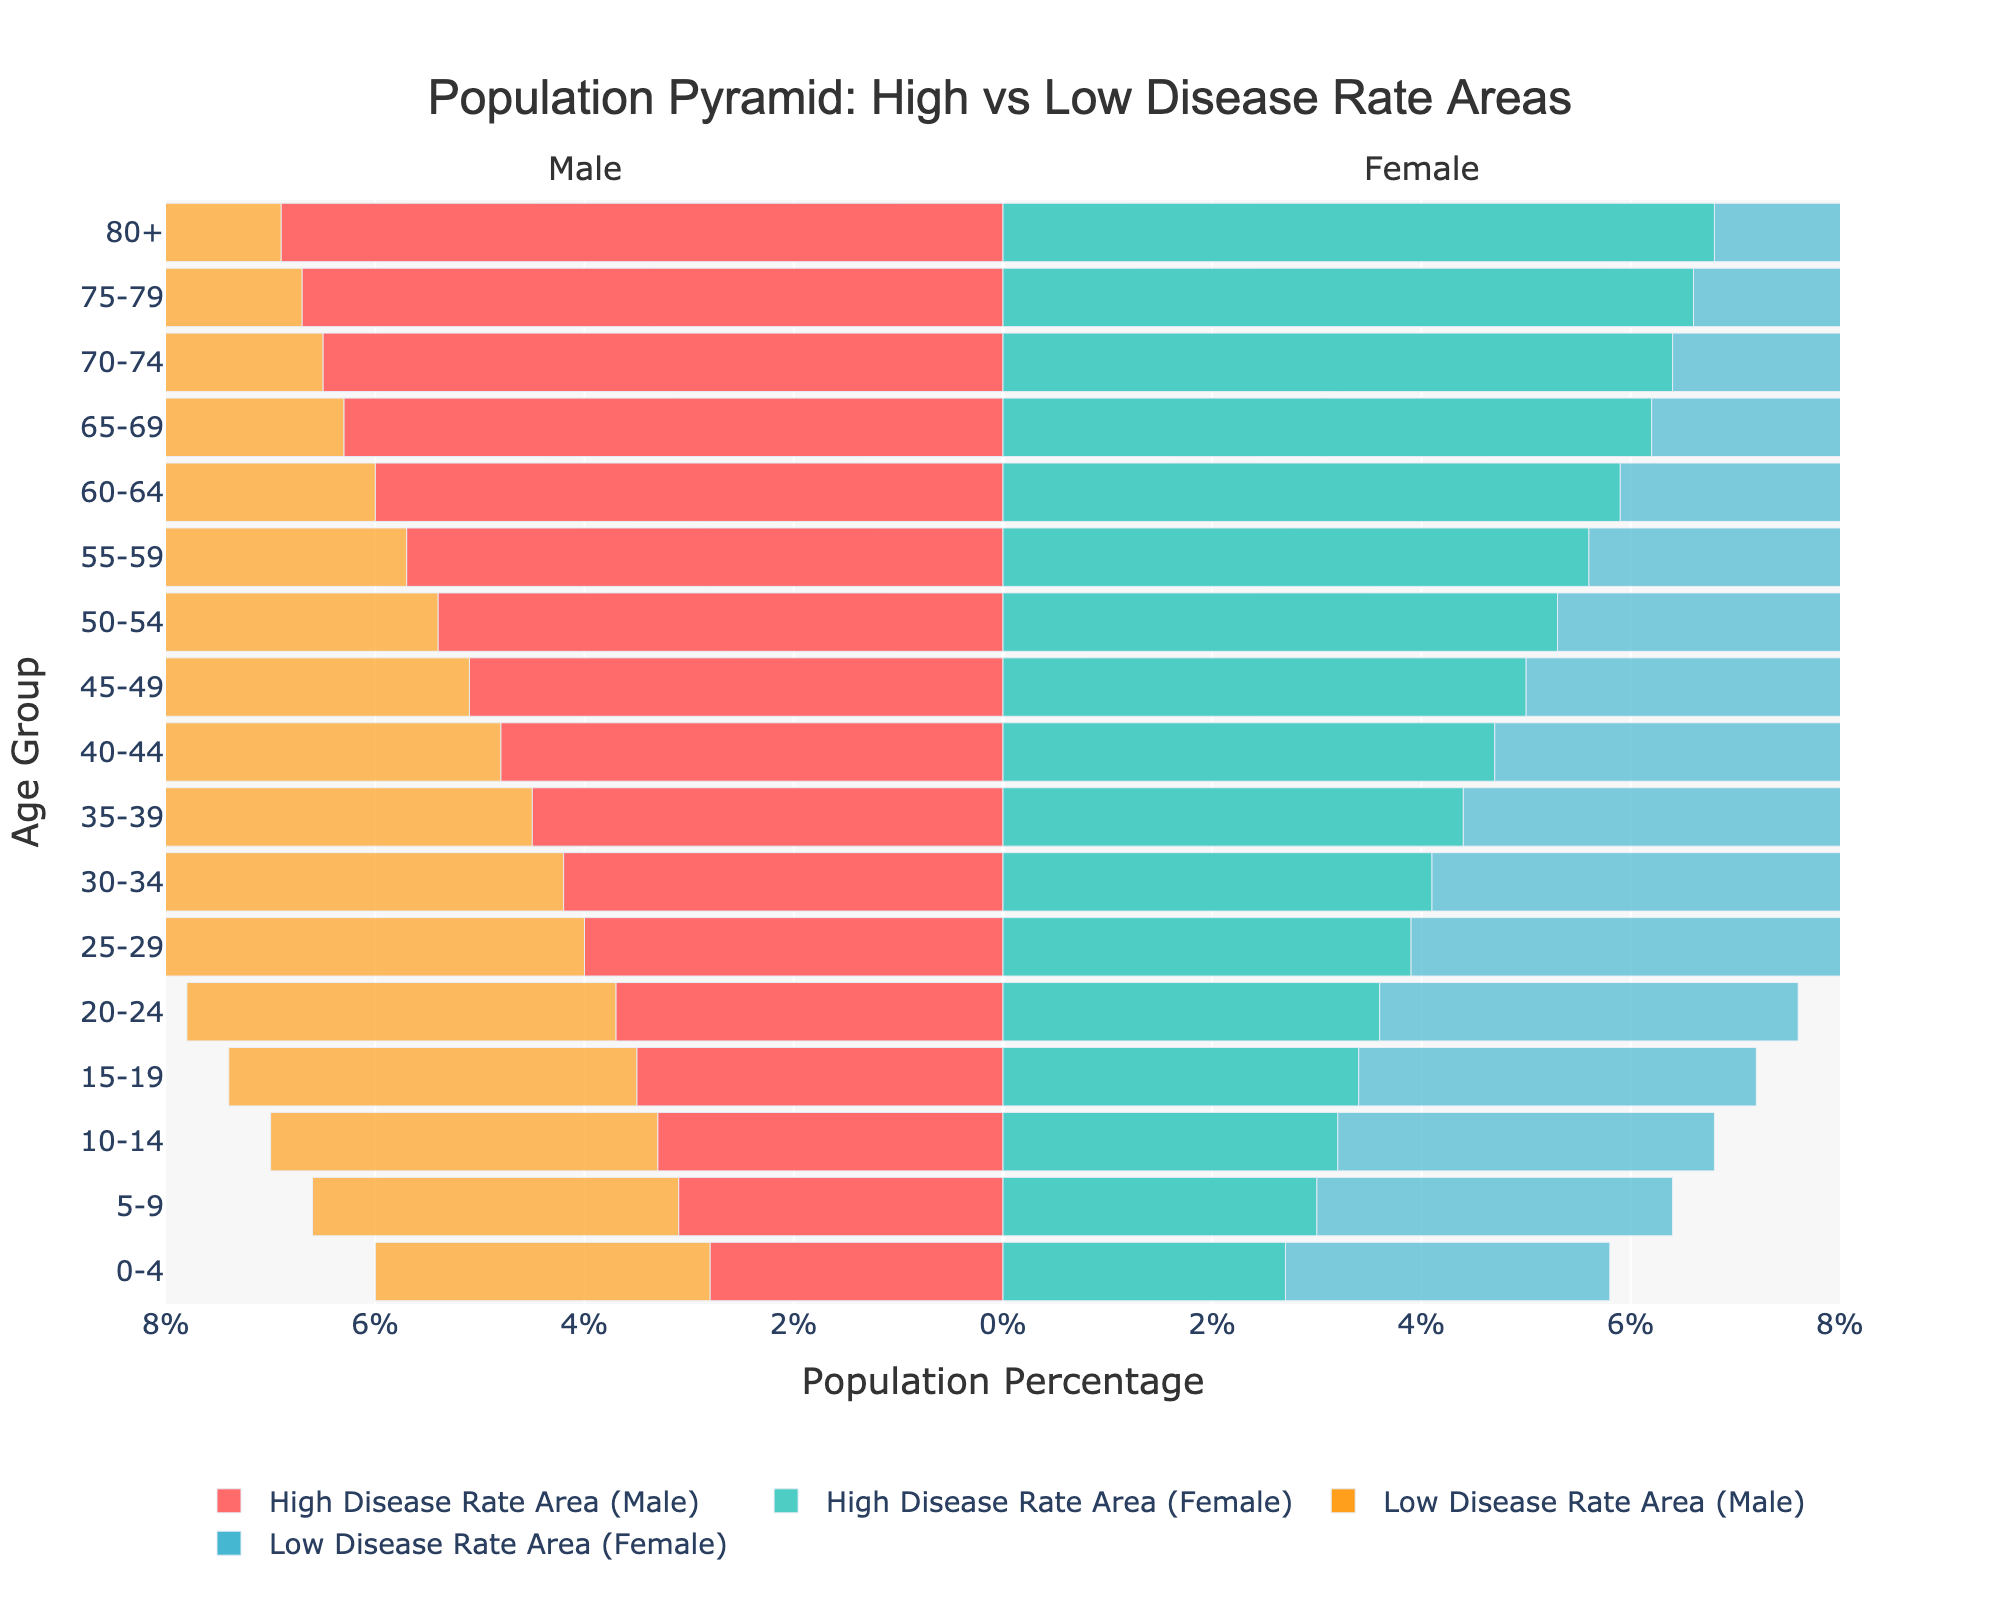what is the title of the chart? The title is typically at the top of the chart and summarises the data you are looking at. Here, the title is "Population Pyramid: High vs Low Disease Rate Areas".
Answer: Population Pyramid: High vs Low Disease Rate Areas Which age group has the highest male population in areas with a high disease rate? Look for the age group where the bar representing "High Disease Rate Area (Male)" extends the furthest to the left.
Answer: 80+ How does the population percentage of females aged 45-49 compare between high and low disease rate areas? Compare the lengths of the bars for "High Disease Rate Area (Female)" and "Low Disease Rate Area (Female)" at the age group 45-49.
Answer: 5.0% vs. 4.9% In the 20-24 age group, what is the difference in the population percentage between males in high disease rate areas and low disease rate areas? Find the values for "High Disease Rate Area (Male)" and "Low Disease Rate Area (Male)" at age group 20-24 and subtract one from the other.
Answer: 0.4% In low disease rate areas, which gender and age group has the least population percentage? Look for the smallest bar lengths for "Low Disease Rate Area (Male)" and "Low Disease Rate Area (Female)" and compare their values.
Answer: Males aged 0-4 How does the population distribution for males and females change as the age increases in high disease rate areas? Observe the trend of the bar lengths for both "High Disease Rate Area (Male)" and "High Disease Rate Area (Female)" as the age groups ascend from 0-4 to 80+.
Answer: Increases with age What is the overall trend for the female population percentages in areas with low disease rates as age increases? Assess the lengths of the bars representing "Low Disease Rate Area (Female)" across the age groups and see if there’s a rising or falling trend.
Answer: Decreases with age What can we infer about the chronic disease rate areas among older age groups based on the population pyramid? Analyze the differences in bar lengths for older age groups (60-64 and above) between high and low disease rate areas for both males and females and deduce any notable trends.
Answer: Higher in high disease rate areas For the age group 30-34, which areas (high or low disease rate) have a higher female population percentage and by how much? Compare the lengths of the bars for "High Disease Rate Area (Female)" and "Low Disease Rate Area (Female)" at age group 30-34 and find the difference.
Answer: Low by 0.3% 